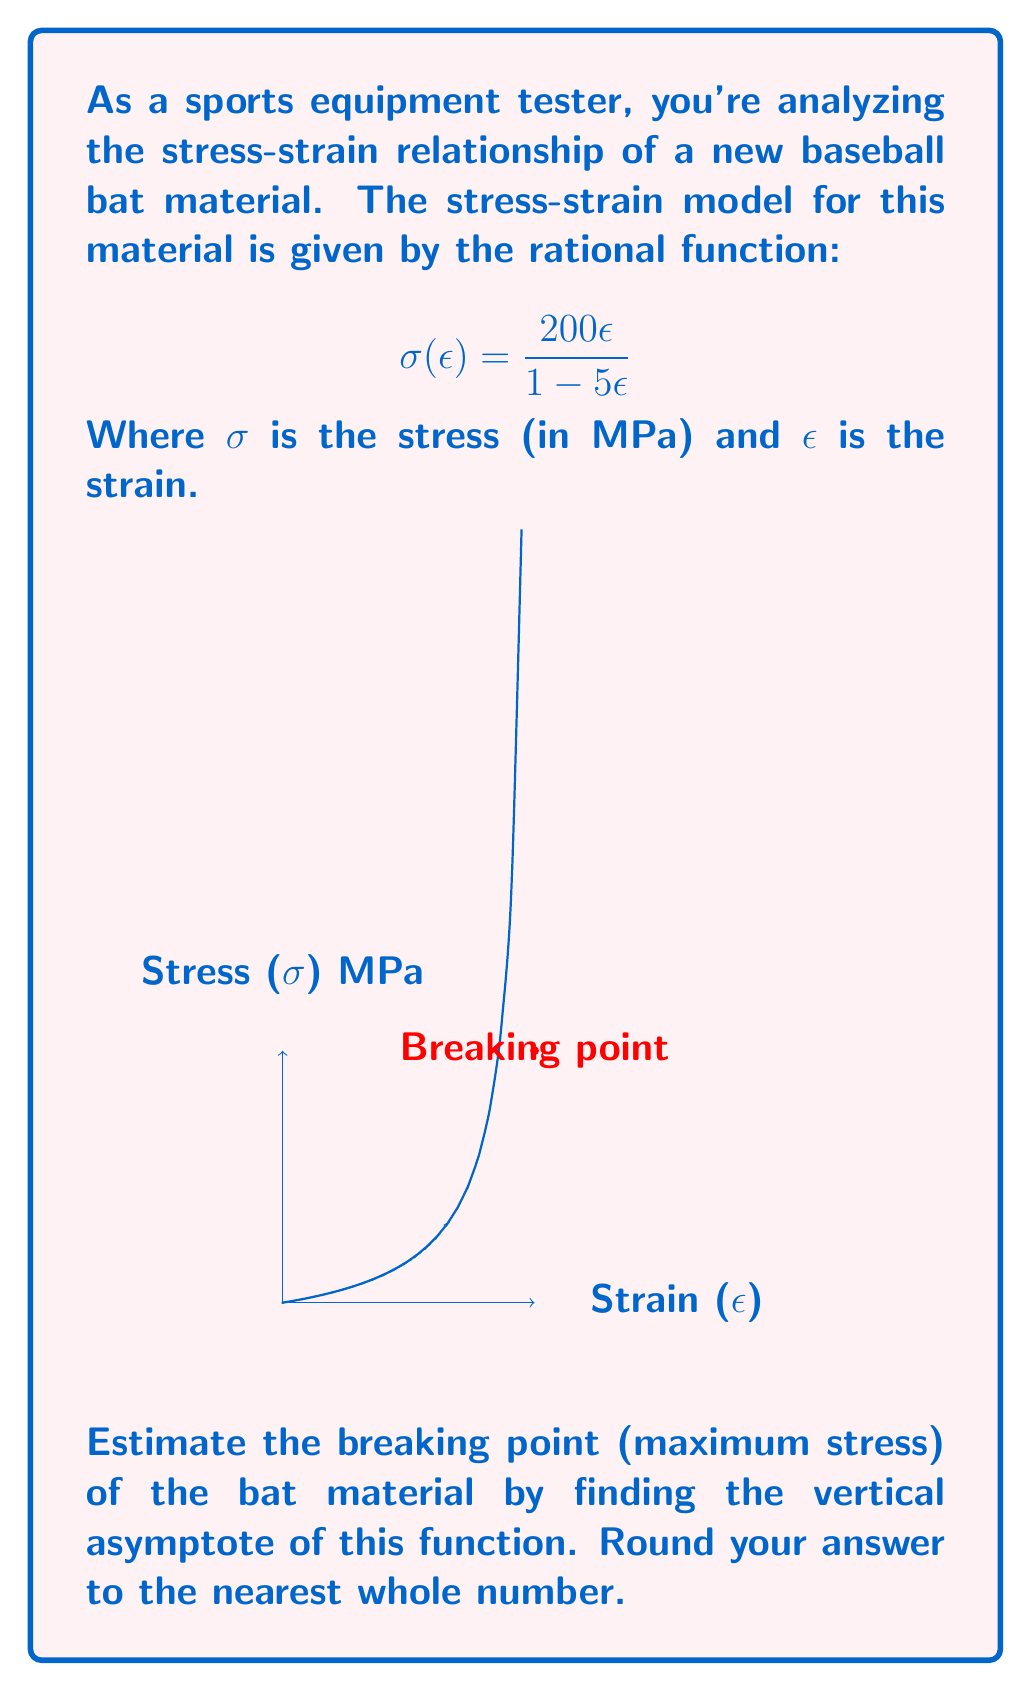Can you solve this math problem? To find the vertical asymptote, we need to determine where the denominator of the rational function equals zero:

1) Set the denominator to zero:
   $1 - 5\epsilon = 0$

2) Solve for $\epsilon$:
   $-5\epsilon = -1$
   $\epsilon = \frac{1}{5} = 0.2$

3) The vertical asymptote occurs at $\epsilon = 0.2$. This represents the strain at which the material would theoretically break.

4) To find the stress at this point, we can evaluate the limit as $\epsilon$ approaches 0.2 from the left:

   $$\lim_{\epsilon \to 0.2^-} \frac{200\epsilon}{1 - 5\epsilon}$$

5) Substituting $\epsilon = 0.1999$ (very close to 0.2):

   $$\sigma(0.1999) = \frac{200(0.1999)}{1 - 5(0.1999)} \approx 249.875 \text{ MPa}$$

6) Rounding to the nearest whole number:
   250 MPa

Therefore, the estimated breaking point (maximum stress) of the bat material is approximately 250 MPa.
Answer: 250 MPa 